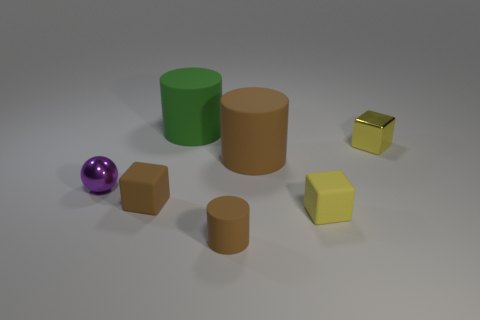How many objects are either cylinders behind the ball or cylinders in front of the small yellow rubber cube? In the image, there are two cylinders behind the purple ball, one that is green and another that is brown. Directly in front of the small yellow cube, there is no cylinder. Therefore, the total count of cylinders either behind the ball or in front of the small yellow cube is two. 